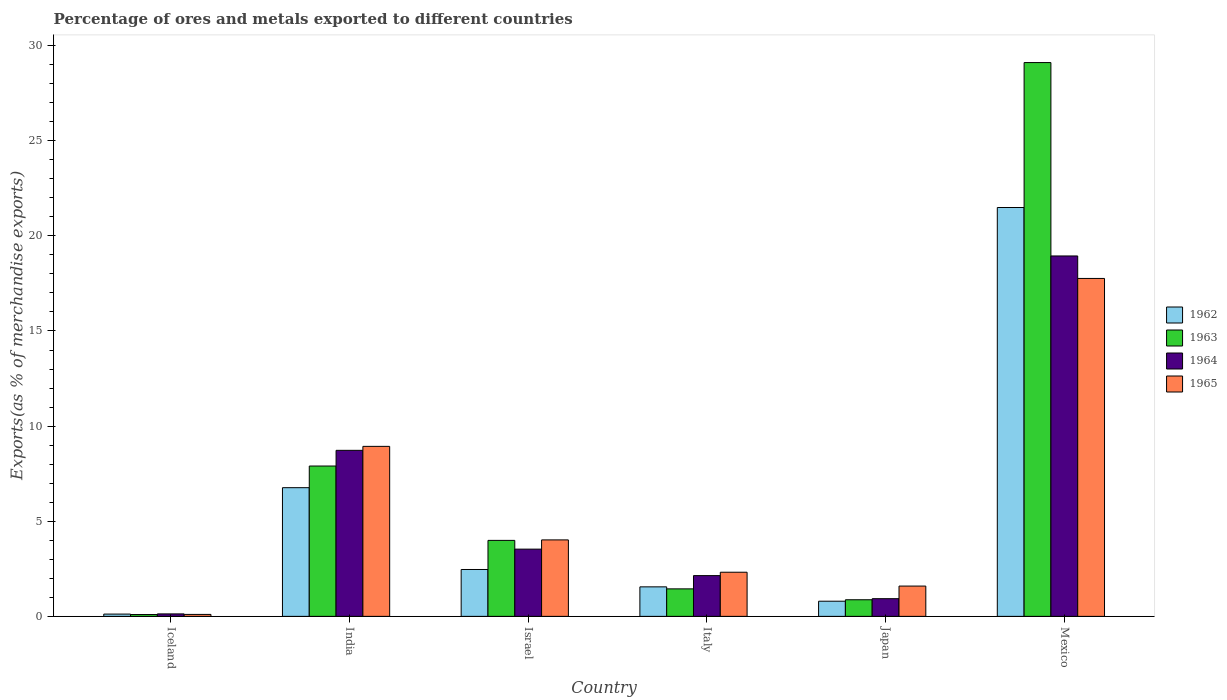Are the number of bars per tick equal to the number of legend labels?
Offer a very short reply. Yes. How many bars are there on the 4th tick from the left?
Offer a terse response. 4. What is the percentage of exports to different countries in 1964 in Mexico?
Give a very brief answer. 18.94. Across all countries, what is the maximum percentage of exports to different countries in 1965?
Your answer should be compact. 17.76. Across all countries, what is the minimum percentage of exports to different countries in 1962?
Your answer should be compact. 0.12. What is the total percentage of exports to different countries in 1962 in the graph?
Offer a terse response. 33.19. What is the difference between the percentage of exports to different countries in 1965 in Japan and that in Mexico?
Your answer should be compact. -16.17. What is the difference between the percentage of exports to different countries in 1962 in Mexico and the percentage of exports to different countries in 1963 in Japan?
Make the answer very short. 20.62. What is the average percentage of exports to different countries in 1962 per country?
Provide a succinct answer. 5.53. What is the difference between the percentage of exports to different countries of/in 1965 and percentage of exports to different countries of/in 1963 in Mexico?
Your answer should be compact. -11.35. In how many countries, is the percentage of exports to different countries in 1963 greater than 1 %?
Ensure brevity in your answer.  4. What is the ratio of the percentage of exports to different countries in 1964 in India to that in Japan?
Offer a terse response. 9.39. Is the percentage of exports to different countries in 1963 in Iceland less than that in Japan?
Provide a succinct answer. Yes. What is the difference between the highest and the second highest percentage of exports to different countries in 1963?
Provide a short and direct response. -25.12. What is the difference between the highest and the lowest percentage of exports to different countries in 1962?
Ensure brevity in your answer.  21.37. Is it the case that in every country, the sum of the percentage of exports to different countries in 1964 and percentage of exports to different countries in 1962 is greater than the sum of percentage of exports to different countries in 1965 and percentage of exports to different countries in 1963?
Ensure brevity in your answer.  No. What does the 1st bar from the left in India represents?
Keep it short and to the point. 1962. Is it the case that in every country, the sum of the percentage of exports to different countries in 1964 and percentage of exports to different countries in 1962 is greater than the percentage of exports to different countries in 1963?
Your response must be concise. Yes. Are all the bars in the graph horizontal?
Make the answer very short. No. How many countries are there in the graph?
Your answer should be very brief. 6. Are the values on the major ticks of Y-axis written in scientific E-notation?
Provide a short and direct response. No. Does the graph contain grids?
Make the answer very short. No. Where does the legend appear in the graph?
Ensure brevity in your answer.  Center right. What is the title of the graph?
Your answer should be very brief. Percentage of ores and metals exported to different countries. Does "1998" appear as one of the legend labels in the graph?
Your response must be concise. No. What is the label or title of the Y-axis?
Your response must be concise. Exports(as % of merchandise exports). What is the Exports(as % of merchandise exports) of 1962 in Iceland?
Provide a succinct answer. 0.12. What is the Exports(as % of merchandise exports) in 1963 in Iceland?
Offer a terse response. 0.1. What is the Exports(as % of merchandise exports) in 1964 in Iceland?
Ensure brevity in your answer.  0.13. What is the Exports(as % of merchandise exports) of 1965 in Iceland?
Make the answer very short. 0.1. What is the Exports(as % of merchandise exports) of 1962 in India?
Provide a short and direct response. 6.76. What is the Exports(as % of merchandise exports) in 1963 in India?
Offer a terse response. 7.9. What is the Exports(as % of merchandise exports) of 1964 in India?
Keep it short and to the point. 8.73. What is the Exports(as % of merchandise exports) of 1965 in India?
Provide a succinct answer. 8.94. What is the Exports(as % of merchandise exports) of 1962 in Israel?
Your answer should be compact. 2.46. What is the Exports(as % of merchandise exports) of 1963 in Israel?
Offer a terse response. 3.99. What is the Exports(as % of merchandise exports) of 1964 in Israel?
Offer a terse response. 3.53. What is the Exports(as % of merchandise exports) of 1965 in Israel?
Provide a short and direct response. 4.02. What is the Exports(as % of merchandise exports) of 1962 in Italy?
Your answer should be very brief. 1.55. What is the Exports(as % of merchandise exports) in 1963 in Italy?
Offer a terse response. 1.45. What is the Exports(as % of merchandise exports) of 1964 in Italy?
Provide a succinct answer. 2.14. What is the Exports(as % of merchandise exports) of 1965 in Italy?
Provide a short and direct response. 2.32. What is the Exports(as % of merchandise exports) in 1962 in Japan?
Provide a succinct answer. 0.8. What is the Exports(as % of merchandise exports) in 1963 in Japan?
Your answer should be compact. 0.87. What is the Exports(as % of merchandise exports) of 1964 in Japan?
Make the answer very short. 0.93. What is the Exports(as % of merchandise exports) in 1965 in Japan?
Your answer should be very brief. 1.59. What is the Exports(as % of merchandise exports) of 1962 in Mexico?
Ensure brevity in your answer.  21.49. What is the Exports(as % of merchandise exports) in 1963 in Mexico?
Ensure brevity in your answer.  29.11. What is the Exports(as % of merchandise exports) of 1964 in Mexico?
Keep it short and to the point. 18.94. What is the Exports(as % of merchandise exports) of 1965 in Mexico?
Offer a very short reply. 17.76. Across all countries, what is the maximum Exports(as % of merchandise exports) in 1962?
Ensure brevity in your answer.  21.49. Across all countries, what is the maximum Exports(as % of merchandise exports) of 1963?
Make the answer very short. 29.11. Across all countries, what is the maximum Exports(as % of merchandise exports) of 1964?
Offer a terse response. 18.94. Across all countries, what is the maximum Exports(as % of merchandise exports) of 1965?
Keep it short and to the point. 17.76. Across all countries, what is the minimum Exports(as % of merchandise exports) of 1962?
Make the answer very short. 0.12. Across all countries, what is the minimum Exports(as % of merchandise exports) in 1963?
Your answer should be very brief. 0.1. Across all countries, what is the minimum Exports(as % of merchandise exports) of 1964?
Ensure brevity in your answer.  0.13. Across all countries, what is the minimum Exports(as % of merchandise exports) in 1965?
Your answer should be compact. 0.1. What is the total Exports(as % of merchandise exports) of 1962 in the graph?
Ensure brevity in your answer.  33.19. What is the total Exports(as % of merchandise exports) in 1963 in the graph?
Offer a terse response. 43.42. What is the total Exports(as % of merchandise exports) in 1964 in the graph?
Keep it short and to the point. 34.41. What is the total Exports(as % of merchandise exports) in 1965 in the graph?
Your response must be concise. 34.73. What is the difference between the Exports(as % of merchandise exports) of 1962 in Iceland and that in India?
Provide a short and direct response. -6.64. What is the difference between the Exports(as % of merchandise exports) of 1963 in Iceland and that in India?
Your response must be concise. -7.81. What is the difference between the Exports(as % of merchandise exports) in 1964 in Iceland and that in India?
Offer a very short reply. -8.6. What is the difference between the Exports(as % of merchandise exports) of 1965 in Iceland and that in India?
Ensure brevity in your answer.  -8.83. What is the difference between the Exports(as % of merchandise exports) in 1962 in Iceland and that in Israel?
Your answer should be very brief. -2.34. What is the difference between the Exports(as % of merchandise exports) in 1963 in Iceland and that in Israel?
Your answer should be compact. -3.9. What is the difference between the Exports(as % of merchandise exports) in 1964 in Iceland and that in Israel?
Your answer should be compact. -3.4. What is the difference between the Exports(as % of merchandise exports) in 1965 in Iceland and that in Israel?
Offer a very short reply. -3.92. What is the difference between the Exports(as % of merchandise exports) in 1962 in Iceland and that in Italy?
Make the answer very short. -1.43. What is the difference between the Exports(as % of merchandise exports) in 1963 in Iceland and that in Italy?
Provide a short and direct response. -1.35. What is the difference between the Exports(as % of merchandise exports) of 1964 in Iceland and that in Italy?
Offer a terse response. -2.01. What is the difference between the Exports(as % of merchandise exports) in 1965 in Iceland and that in Italy?
Give a very brief answer. -2.22. What is the difference between the Exports(as % of merchandise exports) of 1962 in Iceland and that in Japan?
Provide a succinct answer. -0.68. What is the difference between the Exports(as % of merchandise exports) of 1963 in Iceland and that in Japan?
Give a very brief answer. -0.78. What is the difference between the Exports(as % of merchandise exports) in 1964 in Iceland and that in Japan?
Offer a terse response. -0.8. What is the difference between the Exports(as % of merchandise exports) of 1965 in Iceland and that in Japan?
Give a very brief answer. -1.49. What is the difference between the Exports(as % of merchandise exports) of 1962 in Iceland and that in Mexico?
Your response must be concise. -21.37. What is the difference between the Exports(as % of merchandise exports) in 1963 in Iceland and that in Mexico?
Your response must be concise. -29.01. What is the difference between the Exports(as % of merchandise exports) in 1964 in Iceland and that in Mexico?
Ensure brevity in your answer.  -18.81. What is the difference between the Exports(as % of merchandise exports) of 1965 in Iceland and that in Mexico?
Your answer should be compact. -17.66. What is the difference between the Exports(as % of merchandise exports) in 1962 in India and that in Israel?
Provide a short and direct response. 4.3. What is the difference between the Exports(as % of merchandise exports) of 1963 in India and that in Israel?
Offer a very short reply. 3.91. What is the difference between the Exports(as % of merchandise exports) of 1964 in India and that in Israel?
Give a very brief answer. 5.19. What is the difference between the Exports(as % of merchandise exports) in 1965 in India and that in Israel?
Your answer should be very brief. 4.92. What is the difference between the Exports(as % of merchandise exports) in 1962 in India and that in Italy?
Keep it short and to the point. 5.21. What is the difference between the Exports(as % of merchandise exports) of 1963 in India and that in Italy?
Provide a succinct answer. 6.46. What is the difference between the Exports(as % of merchandise exports) of 1964 in India and that in Italy?
Offer a terse response. 6.58. What is the difference between the Exports(as % of merchandise exports) of 1965 in India and that in Italy?
Your answer should be compact. 6.62. What is the difference between the Exports(as % of merchandise exports) of 1962 in India and that in Japan?
Give a very brief answer. 5.97. What is the difference between the Exports(as % of merchandise exports) of 1963 in India and that in Japan?
Offer a very short reply. 7.03. What is the difference between the Exports(as % of merchandise exports) of 1964 in India and that in Japan?
Give a very brief answer. 7.8. What is the difference between the Exports(as % of merchandise exports) of 1965 in India and that in Japan?
Ensure brevity in your answer.  7.34. What is the difference between the Exports(as % of merchandise exports) in 1962 in India and that in Mexico?
Your answer should be compact. -14.73. What is the difference between the Exports(as % of merchandise exports) of 1963 in India and that in Mexico?
Offer a very short reply. -21.21. What is the difference between the Exports(as % of merchandise exports) of 1964 in India and that in Mexico?
Make the answer very short. -10.22. What is the difference between the Exports(as % of merchandise exports) in 1965 in India and that in Mexico?
Make the answer very short. -8.83. What is the difference between the Exports(as % of merchandise exports) in 1962 in Israel and that in Italy?
Give a very brief answer. 0.91. What is the difference between the Exports(as % of merchandise exports) of 1963 in Israel and that in Italy?
Keep it short and to the point. 2.55. What is the difference between the Exports(as % of merchandise exports) in 1964 in Israel and that in Italy?
Give a very brief answer. 1.39. What is the difference between the Exports(as % of merchandise exports) of 1965 in Israel and that in Italy?
Make the answer very short. 1.7. What is the difference between the Exports(as % of merchandise exports) in 1962 in Israel and that in Japan?
Your answer should be compact. 1.67. What is the difference between the Exports(as % of merchandise exports) in 1963 in Israel and that in Japan?
Make the answer very short. 3.12. What is the difference between the Exports(as % of merchandise exports) in 1964 in Israel and that in Japan?
Provide a short and direct response. 2.6. What is the difference between the Exports(as % of merchandise exports) in 1965 in Israel and that in Japan?
Provide a succinct answer. 2.43. What is the difference between the Exports(as % of merchandise exports) in 1962 in Israel and that in Mexico?
Your answer should be very brief. -19.03. What is the difference between the Exports(as % of merchandise exports) of 1963 in Israel and that in Mexico?
Provide a short and direct response. -25.12. What is the difference between the Exports(as % of merchandise exports) of 1964 in Israel and that in Mexico?
Your answer should be compact. -15.41. What is the difference between the Exports(as % of merchandise exports) in 1965 in Israel and that in Mexico?
Your answer should be compact. -13.74. What is the difference between the Exports(as % of merchandise exports) of 1962 in Italy and that in Japan?
Provide a short and direct response. 0.75. What is the difference between the Exports(as % of merchandise exports) of 1963 in Italy and that in Japan?
Your answer should be very brief. 0.57. What is the difference between the Exports(as % of merchandise exports) in 1964 in Italy and that in Japan?
Offer a very short reply. 1.21. What is the difference between the Exports(as % of merchandise exports) of 1965 in Italy and that in Japan?
Your response must be concise. 0.73. What is the difference between the Exports(as % of merchandise exports) of 1962 in Italy and that in Mexico?
Keep it short and to the point. -19.94. What is the difference between the Exports(as % of merchandise exports) of 1963 in Italy and that in Mexico?
Your answer should be very brief. -27.66. What is the difference between the Exports(as % of merchandise exports) of 1964 in Italy and that in Mexico?
Provide a succinct answer. -16.8. What is the difference between the Exports(as % of merchandise exports) in 1965 in Italy and that in Mexico?
Make the answer very short. -15.44. What is the difference between the Exports(as % of merchandise exports) in 1962 in Japan and that in Mexico?
Your answer should be very brief. -20.69. What is the difference between the Exports(as % of merchandise exports) in 1963 in Japan and that in Mexico?
Keep it short and to the point. -28.24. What is the difference between the Exports(as % of merchandise exports) in 1964 in Japan and that in Mexico?
Your response must be concise. -18.01. What is the difference between the Exports(as % of merchandise exports) of 1965 in Japan and that in Mexico?
Provide a short and direct response. -16.17. What is the difference between the Exports(as % of merchandise exports) in 1962 in Iceland and the Exports(as % of merchandise exports) in 1963 in India?
Give a very brief answer. -7.78. What is the difference between the Exports(as % of merchandise exports) in 1962 in Iceland and the Exports(as % of merchandise exports) in 1964 in India?
Provide a succinct answer. -8.61. What is the difference between the Exports(as % of merchandise exports) of 1962 in Iceland and the Exports(as % of merchandise exports) of 1965 in India?
Make the answer very short. -8.82. What is the difference between the Exports(as % of merchandise exports) of 1963 in Iceland and the Exports(as % of merchandise exports) of 1964 in India?
Provide a succinct answer. -8.63. What is the difference between the Exports(as % of merchandise exports) of 1963 in Iceland and the Exports(as % of merchandise exports) of 1965 in India?
Make the answer very short. -8.84. What is the difference between the Exports(as % of merchandise exports) in 1964 in Iceland and the Exports(as % of merchandise exports) in 1965 in India?
Give a very brief answer. -8.81. What is the difference between the Exports(as % of merchandise exports) of 1962 in Iceland and the Exports(as % of merchandise exports) of 1963 in Israel?
Your response must be concise. -3.87. What is the difference between the Exports(as % of merchandise exports) in 1962 in Iceland and the Exports(as % of merchandise exports) in 1964 in Israel?
Keep it short and to the point. -3.41. What is the difference between the Exports(as % of merchandise exports) in 1962 in Iceland and the Exports(as % of merchandise exports) in 1965 in Israel?
Ensure brevity in your answer.  -3.9. What is the difference between the Exports(as % of merchandise exports) in 1963 in Iceland and the Exports(as % of merchandise exports) in 1964 in Israel?
Offer a terse response. -3.44. What is the difference between the Exports(as % of merchandise exports) of 1963 in Iceland and the Exports(as % of merchandise exports) of 1965 in Israel?
Your answer should be very brief. -3.92. What is the difference between the Exports(as % of merchandise exports) of 1964 in Iceland and the Exports(as % of merchandise exports) of 1965 in Israel?
Make the answer very short. -3.89. What is the difference between the Exports(as % of merchandise exports) of 1962 in Iceland and the Exports(as % of merchandise exports) of 1963 in Italy?
Your answer should be very brief. -1.33. What is the difference between the Exports(as % of merchandise exports) of 1962 in Iceland and the Exports(as % of merchandise exports) of 1964 in Italy?
Provide a succinct answer. -2.02. What is the difference between the Exports(as % of merchandise exports) of 1962 in Iceland and the Exports(as % of merchandise exports) of 1965 in Italy?
Your response must be concise. -2.2. What is the difference between the Exports(as % of merchandise exports) in 1963 in Iceland and the Exports(as % of merchandise exports) in 1964 in Italy?
Keep it short and to the point. -2.05. What is the difference between the Exports(as % of merchandise exports) of 1963 in Iceland and the Exports(as % of merchandise exports) of 1965 in Italy?
Your answer should be very brief. -2.22. What is the difference between the Exports(as % of merchandise exports) of 1964 in Iceland and the Exports(as % of merchandise exports) of 1965 in Italy?
Your answer should be compact. -2.19. What is the difference between the Exports(as % of merchandise exports) in 1962 in Iceland and the Exports(as % of merchandise exports) in 1963 in Japan?
Keep it short and to the point. -0.75. What is the difference between the Exports(as % of merchandise exports) of 1962 in Iceland and the Exports(as % of merchandise exports) of 1964 in Japan?
Your answer should be very brief. -0.81. What is the difference between the Exports(as % of merchandise exports) of 1962 in Iceland and the Exports(as % of merchandise exports) of 1965 in Japan?
Make the answer very short. -1.47. What is the difference between the Exports(as % of merchandise exports) in 1963 in Iceland and the Exports(as % of merchandise exports) in 1964 in Japan?
Ensure brevity in your answer.  -0.83. What is the difference between the Exports(as % of merchandise exports) of 1963 in Iceland and the Exports(as % of merchandise exports) of 1965 in Japan?
Offer a very short reply. -1.5. What is the difference between the Exports(as % of merchandise exports) in 1964 in Iceland and the Exports(as % of merchandise exports) in 1965 in Japan?
Your answer should be compact. -1.46. What is the difference between the Exports(as % of merchandise exports) of 1962 in Iceland and the Exports(as % of merchandise exports) of 1963 in Mexico?
Offer a terse response. -28.99. What is the difference between the Exports(as % of merchandise exports) in 1962 in Iceland and the Exports(as % of merchandise exports) in 1964 in Mexico?
Keep it short and to the point. -18.82. What is the difference between the Exports(as % of merchandise exports) of 1962 in Iceland and the Exports(as % of merchandise exports) of 1965 in Mexico?
Your answer should be very brief. -17.64. What is the difference between the Exports(as % of merchandise exports) of 1963 in Iceland and the Exports(as % of merchandise exports) of 1964 in Mexico?
Your answer should be very brief. -18.85. What is the difference between the Exports(as % of merchandise exports) in 1963 in Iceland and the Exports(as % of merchandise exports) in 1965 in Mexico?
Keep it short and to the point. -17.67. What is the difference between the Exports(as % of merchandise exports) in 1964 in Iceland and the Exports(as % of merchandise exports) in 1965 in Mexico?
Provide a short and direct response. -17.63. What is the difference between the Exports(as % of merchandise exports) in 1962 in India and the Exports(as % of merchandise exports) in 1963 in Israel?
Provide a succinct answer. 2.77. What is the difference between the Exports(as % of merchandise exports) in 1962 in India and the Exports(as % of merchandise exports) in 1964 in Israel?
Offer a terse response. 3.23. What is the difference between the Exports(as % of merchandise exports) of 1962 in India and the Exports(as % of merchandise exports) of 1965 in Israel?
Your answer should be compact. 2.74. What is the difference between the Exports(as % of merchandise exports) in 1963 in India and the Exports(as % of merchandise exports) in 1964 in Israel?
Ensure brevity in your answer.  4.37. What is the difference between the Exports(as % of merchandise exports) of 1963 in India and the Exports(as % of merchandise exports) of 1965 in Israel?
Offer a terse response. 3.88. What is the difference between the Exports(as % of merchandise exports) of 1964 in India and the Exports(as % of merchandise exports) of 1965 in Israel?
Make the answer very short. 4.71. What is the difference between the Exports(as % of merchandise exports) of 1962 in India and the Exports(as % of merchandise exports) of 1963 in Italy?
Make the answer very short. 5.32. What is the difference between the Exports(as % of merchandise exports) in 1962 in India and the Exports(as % of merchandise exports) in 1964 in Italy?
Offer a terse response. 4.62. What is the difference between the Exports(as % of merchandise exports) of 1962 in India and the Exports(as % of merchandise exports) of 1965 in Italy?
Make the answer very short. 4.44. What is the difference between the Exports(as % of merchandise exports) in 1963 in India and the Exports(as % of merchandise exports) in 1964 in Italy?
Make the answer very short. 5.76. What is the difference between the Exports(as % of merchandise exports) of 1963 in India and the Exports(as % of merchandise exports) of 1965 in Italy?
Your answer should be compact. 5.58. What is the difference between the Exports(as % of merchandise exports) of 1964 in India and the Exports(as % of merchandise exports) of 1965 in Italy?
Your response must be concise. 6.41. What is the difference between the Exports(as % of merchandise exports) of 1962 in India and the Exports(as % of merchandise exports) of 1963 in Japan?
Offer a very short reply. 5.89. What is the difference between the Exports(as % of merchandise exports) of 1962 in India and the Exports(as % of merchandise exports) of 1964 in Japan?
Keep it short and to the point. 5.83. What is the difference between the Exports(as % of merchandise exports) in 1962 in India and the Exports(as % of merchandise exports) in 1965 in Japan?
Give a very brief answer. 5.17. What is the difference between the Exports(as % of merchandise exports) of 1963 in India and the Exports(as % of merchandise exports) of 1964 in Japan?
Your answer should be very brief. 6.97. What is the difference between the Exports(as % of merchandise exports) of 1963 in India and the Exports(as % of merchandise exports) of 1965 in Japan?
Ensure brevity in your answer.  6.31. What is the difference between the Exports(as % of merchandise exports) of 1964 in India and the Exports(as % of merchandise exports) of 1965 in Japan?
Offer a terse response. 7.13. What is the difference between the Exports(as % of merchandise exports) of 1962 in India and the Exports(as % of merchandise exports) of 1963 in Mexico?
Give a very brief answer. -22.35. What is the difference between the Exports(as % of merchandise exports) in 1962 in India and the Exports(as % of merchandise exports) in 1964 in Mexico?
Provide a short and direct response. -12.18. What is the difference between the Exports(as % of merchandise exports) of 1962 in India and the Exports(as % of merchandise exports) of 1965 in Mexico?
Provide a short and direct response. -11. What is the difference between the Exports(as % of merchandise exports) in 1963 in India and the Exports(as % of merchandise exports) in 1964 in Mexico?
Offer a terse response. -11.04. What is the difference between the Exports(as % of merchandise exports) in 1963 in India and the Exports(as % of merchandise exports) in 1965 in Mexico?
Offer a terse response. -9.86. What is the difference between the Exports(as % of merchandise exports) of 1964 in India and the Exports(as % of merchandise exports) of 1965 in Mexico?
Your answer should be very brief. -9.03. What is the difference between the Exports(as % of merchandise exports) of 1962 in Israel and the Exports(as % of merchandise exports) of 1963 in Italy?
Give a very brief answer. 1.02. What is the difference between the Exports(as % of merchandise exports) in 1962 in Israel and the Exports(as % of merchandise exports) in 1964 in Italy?
Your answer should be very brief. 0.32. What is the difference between the Exports(as % of merchandise exports) in 1962 in Israel and the Exports(as % of merchandise exports) in 1965 in Italy?
Provide a succinct answer. 0.14. What is the difference between the Exports(as % of merchandise exports) of 1963 in Israel and the Exports(as % of merchandise exports) of 1964 in Italy?
Offer a very short reply. 1.85. What is the difference between the Exports(as % of merchandise exports) in 1963 in Israel and the Exports(as % of merchandise exports) in 1965 in Italy?
Provide a succinct answer. 1.67. What is the difference between the Exports(as % of merchandise exports) of 1964 in Israel and the Exports(as % of merchandise exports) of 1965 in Italy?
Your answer should be compact. 1.21. What is the difference between the Exports(as % of merchandise exports) of 1962 in Israel and the Exports(as % of merchandise exports) of 1963 in Japan?
Your response must be concise. 1.59. What is the difference between the Exports(as % of merchandise exports) of 1962 in Israel and the Exports(as % of merchandise exports) of 1964 in Japan?
Your answer should be compact. 1.53. What is the difference between the Exports(as % of merchandise exports) of 1962 in Israel and the Exports(as % of merchandise exports) of 1965 in Japan?
Keep it short and to the point. 0.87. What is the difference between the Exports(as % of merchandise exports) of 1963 in Israel and the Exports(as % of merchandise exports) of 1964 in Japan?
Your response must be concise. 3.06. What is the difference between the Exports(as % of merchandise exports) of 1963 in Israel and the Exports(as % of merchandise exports) of 1965 in Japan?
Your response must be concise. 2.4. What is the difference between the Exports(as % of merchandise exports) in 1964 in Israel and the Exports(as % of merchandise exports) in 1965 in Japan?
Provide a succinct answer. 1.94. What is the difference between the Exports(as % of merchandise exports) in 1962 in Israel and the Exports(as % of merchandise exports) in 1963 in Mexico?
Offer a very short reply. -26.64. What is the difference between the Exports(as % of merchandise exports) of 1962 in Israel and the Exports(as % of merchandise exports) of 1964 in Mexico?
Make the answer very short. -16.48. What is the difference between the Exports(as % of merchandise exports) in 1962 in Israel and the Exports(as % of merchandise exports) in 1965 in Mexico?
Provide a short and direct response. -15.3. What is the difference between the Exports(as % of merchandise exports) in 1963 in Israel and the Exports(as % of merchandise exports) in 1964 in Mexico?
Ensure brevity in your answer.  -14.95. What is the difference between the Exports(as % of merchandise exports) in 1963 in Israel and the Exports(as % of merchandise exports) in 1965 in Mexico?
Offer a terse response. -13.77. What is the difference between the Exports(as % of merchandise exports) in 1964 in Israel and the Exports(as % of merchandise exports) in 1965 in Mexico?
Provide a succinct answer. -14.23. What is the difference between the Exports(as % of merchandise exports) in 1962 in Italy and the Exports(as % of merchandise exports) in 1963 in Japan?
Give a very brief answer. 0.68. What is the difference between the Exports(as % of merchandise exports) of 1962 in Italy and the Exports(as % of merchandise exports) of 1964 in Japan?
Your answer should be compact. 0.62. What is the difference between the Exports(as % of merchandise exports) in 1962 in Italy and the Exports(as % of merchandise exports) in 1965 in Japan?
Offer a very short reply. -0.04. What is the difference between the Exports(as % of merchandise exports) in 1963 in Italy and the Exports(as % of merchandise exports) in 1964 in Japan?
Ensure brevity in your answer.  0.52. What is the difference between the Exports(as % of merchandise exports) of 1963 in Italy and the Exports(as % of merchandise exports) of 1965 in Japan?
Make the answer very short. -0.15. What is the difference between the Exports(as % of merchandise exports) in 1964 in Italy and the Exports(as % of merchandise exports) in 1965 in Japan?
Give a very brief answer. 0.55. What is the difference between the Exports(as % of merchandise exports) of 1962 in Italy and the Exports(as % of merchandise exports) of 1963 in Mexico?
Offer a terse response. -27.56. What is the difference between the Exports(as % of merchandise exports) of 1962 in Italy and the Exports(as % of merchandise exports) of 1964 in Mexico?
Your answer should be very brief. -17.39. What is the difference between the Exports(as % of merchandise exports) in 1962 in Italy and the Exports(as % of merchandise exports) in 1965 in Mexico?
Your answer should be compact. -16.21. What is the difference between the Exports(as % of merchandise exports) of 1963 in Italy and the Exports(as % of merchandise exports) of 1964 in Mexico?
Offer a very short reply. -17.5. What is the difference between the Exports(as % of merchandise exports) in 1963 in Italy and the Exports(as % of merchandise exports) in 1965 in Mexico?
Offer a terse response. -16.32. What is the difference between the Exports(as % of merchandise exports) of 1964 in Italy and the Exports(as % of merchandise exports) of 1965 in Mexico?
Provide a short and direct response. -15.62. What is the difference between the Exports(as % of merchandise exports) of 1962 in Japan and the Exports(as % of merchandise exports) of 1963 in Mexico?
Keep it short and to the point. -28.31. What is the difference between the Exports(as % of merchandise exports) of 1962 in Japan and the Exports(as % of merchandise exports) of 1964 in Mexico?
Offer a very short reply. -18.15. What is the difference between the Exports(as % of merchandise exports) in 1962 in Japan and the Exports(as % of merchandise exports) in 1965 in Mexico?
Ensure brevity in your answer.  -16.97. What is the difference between the Exports(as % of merchandise exports) of 1963 in Japan and the Exports(as % of merchandise exports) of 1964 in Mexico?
Make the answer very short. -18.07. What is the difference between the Exports(as % of merchandise exports) of 1963 in Japan and the Exports(as % of merchandise exports) of 1965 in Mexico?
Offer a terse response. -16.89. What is the difference between the Exports(as % of merchandise exports) of 1964 in Japan and the Exports(as % of merchandise exports) of 1965 in Mexico?
Offer a very short reply. -16.83. What is the average Exports(as % of merchandise exports) in 1962 per country?
Your response must be concise. 5.53. What is the average Exports(as % of merchandise exports) of 1963 per country?
Provide a short and direct response. 7.24. What is the average Exports(as % of merchandise exports) of 1964 per country?
Give a very brief answer. 5.73. What is the average Exports(as % of merchandise exports) in 1965 per country?
Your answer should be very brief. 5.79. What is the difference between the Exports(as % of merchandise exports) in 1962 and Exports(as % of merchandise exports) in 1963 in Iceland?
Give a very brief answer. 0.02. What is the difference between the Exports(as % of merchandise exports) in 1962 and Exports(as % of merchandise exports) in 1964 in Iceland?
Keep it short and to the point. -0.01. What is the difference between the Exports(as % of merchandise exports) in 1962 and Exports(as % of merchandise exports) in 1965 in Iceland?
Provide a succinct answer. 0.02. What is the difference between the Exports(as % of merchandise exports) in 1963 and Exports(as % of merchandise exports) in 1964 in Iceland?
Offer a terse response. -0.03. What is the difference between the Exports(as % of merchandise exports) in 1963 and Exports(as % of merchandise exports) in 1965 in Iceland?
Provide a short and direct response. -0.01. What is the difference between the Exports(as % of merchandise exports) in 1964 and Exports(as % of merchandise exports) in 1965 in Iceland?
Provide a short and direct response. 0.03. What is the difference between the Exports(as % of merchandise exports) of 1962 and Exports(as % of merchandise exports) of 1963 in India?
Offer a terse response. -1.14. What is the difference between the Exports(as % of merchandise exports) in 1962 and Exports(as % of merchandise exports) in 1964 in India?
Your response must be concise. -1.96. What is the difference between the Exports(as % of merchandise exports) in 1962 and Exports(as % of merchandise exports) in 1965 in India?
Offer a terse response. -2.17. What is the difference between the Exports(as % of merchandise exports) in 1963 and Exports(as % of merchandise exports) in 1964 in India?
Offer a very short reply. -0.82. What is the difference between the Exports(as % of merchandise exports) in 1963 and Exports(as % of merchandise exports) in 1965 in India?
Your answer should be compact. -1.03. What is the difference between the Exports(as % of merchandise exports) of 1964 and Exports(as % of merchandise exports) of 1965 in India?
Make the answer very short. -0.21. What is the difference between the Exports(as % of merchandise exports) in 1962 and Exports(as % of merchandise exports) in 1963 in Israel?
Make the answer very short. -1.53. What is the difference between the Exports(as % of merchandise exports) of 1962 and Exports(as % of merchandise exports) of 1964 in Israel?
Keep it short and to the point. -1.07. What is the difference between the Exports(as % of merchandise exports) in 1962 and Exports(as % of merchandise exports) in 1965 in Israel?
Offer a terse response. -1.56. What is the difference between the Exports(as % of merchandise exports) in 1963 and Exports(as % of merchandise exports) in 1964 in Israel?
Make the answer very short. 0.46. What is the difference between the Exports(as % of merchandise exports) of 1963 and Exports(as % of merchandise exports) of 1965 in Israel?
Offer a terse response. -0.03. What is the difference between the Exports(as % of merchandise exports) in 1964 and Exports(as % of merchandise exports) in 1965 in Israel?
Your answer should be very brief. -0.49. What is the difference between the Exports(as % of merchandise exports) of 1962 and Exports(as % of merchandise exports) of 1963 in Italy?
Offer a terse response. 0.11. What is the difference between the Exports(as % of merchandise exports) in 1962 and Exports(as % of merchandise exports) in 1964 in Italy?
Your answer should be compact. -0.59. What is the difference between the Exports(as % of merchandise exports) in 1962 and Exports(as % of merchandise exports) in 1965 in Italy?
Keep it short and to the point. -0.77. What is the difference between the Exports(as % of merchandise exports) in 1963 and Exports(as % of merchandise exports) in 1964 in Italy?
Offer a terse response. -0.7. What is the difference between the Exports(as % of merchandise exports) of 1963 and Exports(as % of merchandise exports) of 1965 in Italy?
Your response must be concise. -0.87. What is the difference between the Exports(as % of merchandise exports) in 1964 and Exports(as % of merchandise exports) in 1965 in Italy?
Provide a succinct answer. -0.18. What is the difference between the Exports(as % of merchandise exports) of 1962 and Exports(as % of merchandise exports) of 1963 in Japan?
Offer a very short reply. -0.08. What is the difference between the Exports(as % of merchandise exports) in 1962 and Exports(as % of merchandise exports) in 1964 in Japan?
Ensure brevity in your answer.  -0.13. What is the difference between the Exports(as % of merchandise exports) of 1962 and Exports(as % of merchandise exports) of 1965 in Japan?
Your answer should be compact. -0.8. What is the difference between the Exports(as % of merchandise exports) of 1963 and Exports(as % of merchandise exports) of 1964 in Japan?
Offer a very short reply. -0.06. What is the difference between the Exports(as % of merchandise exports) of 1963 and Exports(as % of merchandise exports) of 1965 in Japan?
Provide a short and direct response. -0.72. What is the difference between the Exports(as % of merchandise exports) of 1964 and Exports(as % of merchandise exports) of 1965 in Japan?
Provide a succinct answer. -0.66. What is the difference between the Exports(as % of merchandise exports) in 1962 and Exports(as % of merchandise exports) in 1963 in Mexico?
Give a very brief answer. -7.62. What is the difference between the Exports(as % of merchandise exports) in 1962 and Exports(as % of merchandise exports) in 1964 in Mexico?
Your answer should be very brief. 2.55. What is the difference between the Exports(as % of merchandise exports) of 1962 and Exports(as % of merchandise exports) of 1965 in Mexico?
Offer a very short reply. 3.73. What is the difference between the Exports(as % of merchandise exports) in 1963 and Exports(as % of merchandise exports) in 1964 in Mexico?
Your answer should be compact. 10.16. What is the difference between the Exports(as % of merchandise exports) in 1963 and Exports(as % of merchandise exports) in 1965 in Mexico?
Make the answer very short. 11.35. What is the difference between the Exports(as % of merchandise exports) in 1964 and Exports(as % of merchandise exports) in 1965 in Mexico?
Keep it short and to the point. 1.18. What is the ratio of the Exports(as % of merchandise exports) of 1962 in Iceland to that in India?
Keep it short and to the point. 0.02. What is the ratio of the Exports(as % of merchandise exports) of 1963 in Iceland to that in India?
Your answer should be compact. 0.01. What is the ratio of the Exports(as % of merchandise exports) of 1964 in Iceland to that in India?
Provide a succinct answer. 0.01. What is the ratio of the Exports(as % of merchandise exports) of 1965 in Iceland to that in India?
Offer a terse response. 0.01. What is the ratio of the Exports(as % of merchandise exports) of 1962 in Iceland to that in Israel?
Offer a terse response. 0.05. What is the ratio of the Exports(as % of merchandise exports) of 1963 in Iceland to that in Israel?
Your answer should be compact. 0.02. What is the ratio of the Exports(as % of merchandise exports) in 1964 in Iceland to that in Israel?
Provide a succinct answer. 0.04. What is the ratio of the Exports(as % of merchandise exports) in 1965 in Iceland to that in Israel?
Give a very brief answer. 0.03. What is the ratio of the Exports(as % of merchandise exports) in 1962 in Iceland to that in Italy?
Give a very brief answer. 0.08. What is the ratio of the Exports(as % of merchandise exports) of 1963 in Iceland to that in Italy?
Your response must be concise. 0.07. What is the ratio of the Exports(as % of merchandise exports) in 1964 in Iceland to that in Italy?
Provide a succinct answer. 0.06. What is the ratio of the Exports(as % of merchandise exports) in 1965 in Iceland to that in Italy?
Provide a succinct answer. 0.04. What is the ratio of the Exports(as % of merchandise exports) in 1962 in Iceland to that in Japan?
Keep it short and to the point. 0.15. What is the ratio of the Exports(as % of merchandise exports) of 1963 in Iceland to that in Japan?
Your answer should be very brief. 0.11. What is the ratio of the Exports(as % of merchandise exports) in 1964 in Iceland to that in Japan?
Your response must be concise. 0.14. What is the ratio of the Exports(as % of merchandise exports) in 1965 in Iceland to that in Japan?
Provide a succinct answer. 0.06. What is the ratio of the Exports(as % of merchandise exports) of 1962 in Iceland to that in Mexico?
Your answer should be compact. 0.01. What is the ratio of the Exports(as % of merchandise exports) of 1963 in Iceland to that in Mexico?
Make the answer very short. 0. What is the ratio of the Exports(as % of merchandise exports) of 1964 in Iceland to that in Mexico?
Ensure brevity in your answer.  0.01. What is the ratio of the Exports(as % of merchandise exports) of 1965 in Iceland to that in Mexico?
Your response must be concise. 0.01. What is the ratio of the Exports(as % of merchandise exports) of 1962 in India to that in Israel?
Offer a terse response. 2.75. What is the ratio of the Exports(as % of merchandise exports) of 1963 in India to that in Israel?
Your answer should be very brief. 1.98. What is the ratio of the Exports(as % of merchandise exports) in 1964 in India to that in Israel?
Your answer should be very brief. 2.47. What is the ratio of the Exports(as % of merchandise exports) of 1965 in India to that in Israel?
Give a very brief answer. 2.22. What is the ratio of the Exports(as % of merchandise exports) of 1962 in India to that in Italy?
Ensure brevity in your answer.  4.36. What is the ratio of the Exports(as % of merchandise exports) of 1963 in India to that in Italy?
Ensure brevity in your answer.  5.47. What is the ratio of the Exports(as % of merchandise exports) in 1964 in India to that in Italy?
Keep it short and to the point. 4.07. What is the ratio of the Exports(as % of merchandise exports) of 1965 in India to that in Italy?
Keep it short and to the point. 3.85. What is the ratio of the Exports(as % of merchandise exports) of 1962 in India to that in Japan?
Ensure brevity in your answer.  8.49. What is the ratio of the Exports(as % of merchandise exports) in 1963 in India to that in Japan?
Make the answer very short. 9.05. What is the ratio of the Exports(as % of merchandise exports) of 1964 in India to that in Japan?
Provide a succinct answer. 9.39. What is the ratio of the Exports(as % of merchandise exports) in 1965 in India to that in Japan?
Ensure brevity in your answer.  5.61. What is the ratio of the Exports(as % of merchandise exports) in 1962 in India to that in Mexico?
Provide a succinct answer. 0.31. What is the ratio of the Exports(as % of merchandise exports) of 1963 in India to that in Mexico?
Provide a short and direct response. 0.27. What is the ratio of the Exports(as % of merchandise exports) of 1964 in India to that in Mexico?
Provide a succinct answer. 0.46. What is the ratio of the Exports(as % of merchandise exports) in 1965 in India to that in Mexico?
Provide a short and direct response. 0.5. What is the ratio of the Exports(as % of merchandise exports) of 1962 in Israel to that in Italy?
Your response must be concise. 1.59. What is the ratio of the Exports(as % of merchandise exports) in 1963 in Israel to that in Italy?
Provide a succinct answer. 2.76. What is the ratio of the Exports(as % of merchandise exports) in 1964 in Israel to that in Italy?
Your response must be concise. 1.65. What is the ratio of the Exports(as % of merchandise exports) in 1965 in Israel to that in Italy?
Offer a very short reply. 1.73. What is the ratio of the Exports(as % of merchandise exports) of 1962 in Israel to that in Japan?
Provide a short and direct response. 3.09. What is the ratio of the Exports(as % of merchandise exports) of 1963 in Israel to that in Japan?
Your response must be concise. 4.57. What is the ratio of the Exports(as % of merchandise exports) in 1964 in Israel to that in Japan?
Provide a succinct answer. 3.8. What is the ratio of the Exports(as % of merchandise exports) in 1965 in Israel to that in Japan?
Give a very brief answer. 2.52. What is the ratio of the Exports(as % of merchandise exports) of 1962 in Israel to that in Mexico?
Keep it short and to the point. 0.11. What is the ratio of the Exports(as % of merchandise exports) in 1963 in Israel to that in Mexico?
Ensure brevity in your answer.  0.14. What is the ratio of the Exports(as % of merchandise exports) in 1964 in Israel to that in Mexico?
Offer a terse response. 0.19. What is the ratio of the Exports(as % of merchandise exports) in 1965 in Israel to that in Mexico?
Provide a short and direct response. 0.23. What is the ratio of the Exports(as % of merchandise exports) of 1962 in Italy to that in Japan?
Your answer should be very brief. 1.95. What is the ratio of the Exports(as % of merchandise exports) in 1963 in Italy to that in Japan?
Your response must be concise. 1.66. What is the ratio of the Exports(as % of merchandise exports) of 1964 in Italy to that in Japan?
Make the answer very short. 2.31. What is the ratio of the Exports(as % of merchandise exports) in 1965 in Italy to that in Japan?
Offer a very short reply. 1.46. What is the ratio of the Exports(as % of merchandise exports) of 1962 in Italy to that in Mexico?
Your response must be concise. 0.07. What is the ratio of the Exports(as % of merchandise exports) of 1963 in Italy to that in Mexico?
Your answer should be compact. 0.05. What is the ratio of the Exports(as % of merchandise exports) in 1964 in Italy to that in Mexico?
Ensure brevity in your answer.  0.11. What is the ratio of the Exports(as % of merchandise exports) of 1965 in Italy to that in Mexico?
Give a very brief answer. 0.13. What is the ratio of the Exports(as % of merchandise exports) of 1962 in Japan to that in Mexico?
Your answer should be very brief. 0.04. What is the ratio of the Exports(as % of merchandise exports) in 1964 in Japan to that in Mexico?
Provide a succinct answer. 0.05. What is the ratio of the Exports(as % of merchandise exports) of 1965 in Japan to that in Mexico?
Make the answer very short. 0.09. What is the difference between the highest and the second highest Exports(as % of merchandise exports) in 1962?
Your answer should be very brief. 14.73. What is the difference between the highest and the second highest Exports(as % of merchandise exports) in 1963?
Your answer should be very brief. 21.21. What is the difference between the highest and the second highest Exports(as % of merchandise exports) of 1964?
Your response must be concise. 10.22. What is the difference between the highest and the second highest Exports(as % of merchandise exports) of 1965?
Keep it short and to the point. 8.83. What is the difference between the highest and the lowest Exports(as % of merchandise exports) of 1962?
Offer a terse response. 21.37. What is the difference between the highest and the lowest Exports(as % of merchandise exports) of 1963?
Offer a terse response. 29.01. What is the difference between the highest and the lowest Exports(as % of merchandise exports) of 1964?
Keep it short and to the point. 18.81. What is the difference between the highest and the lowest Exports(as % of merchandise exports) in 1965?
Your response must be concise. 17.66. 